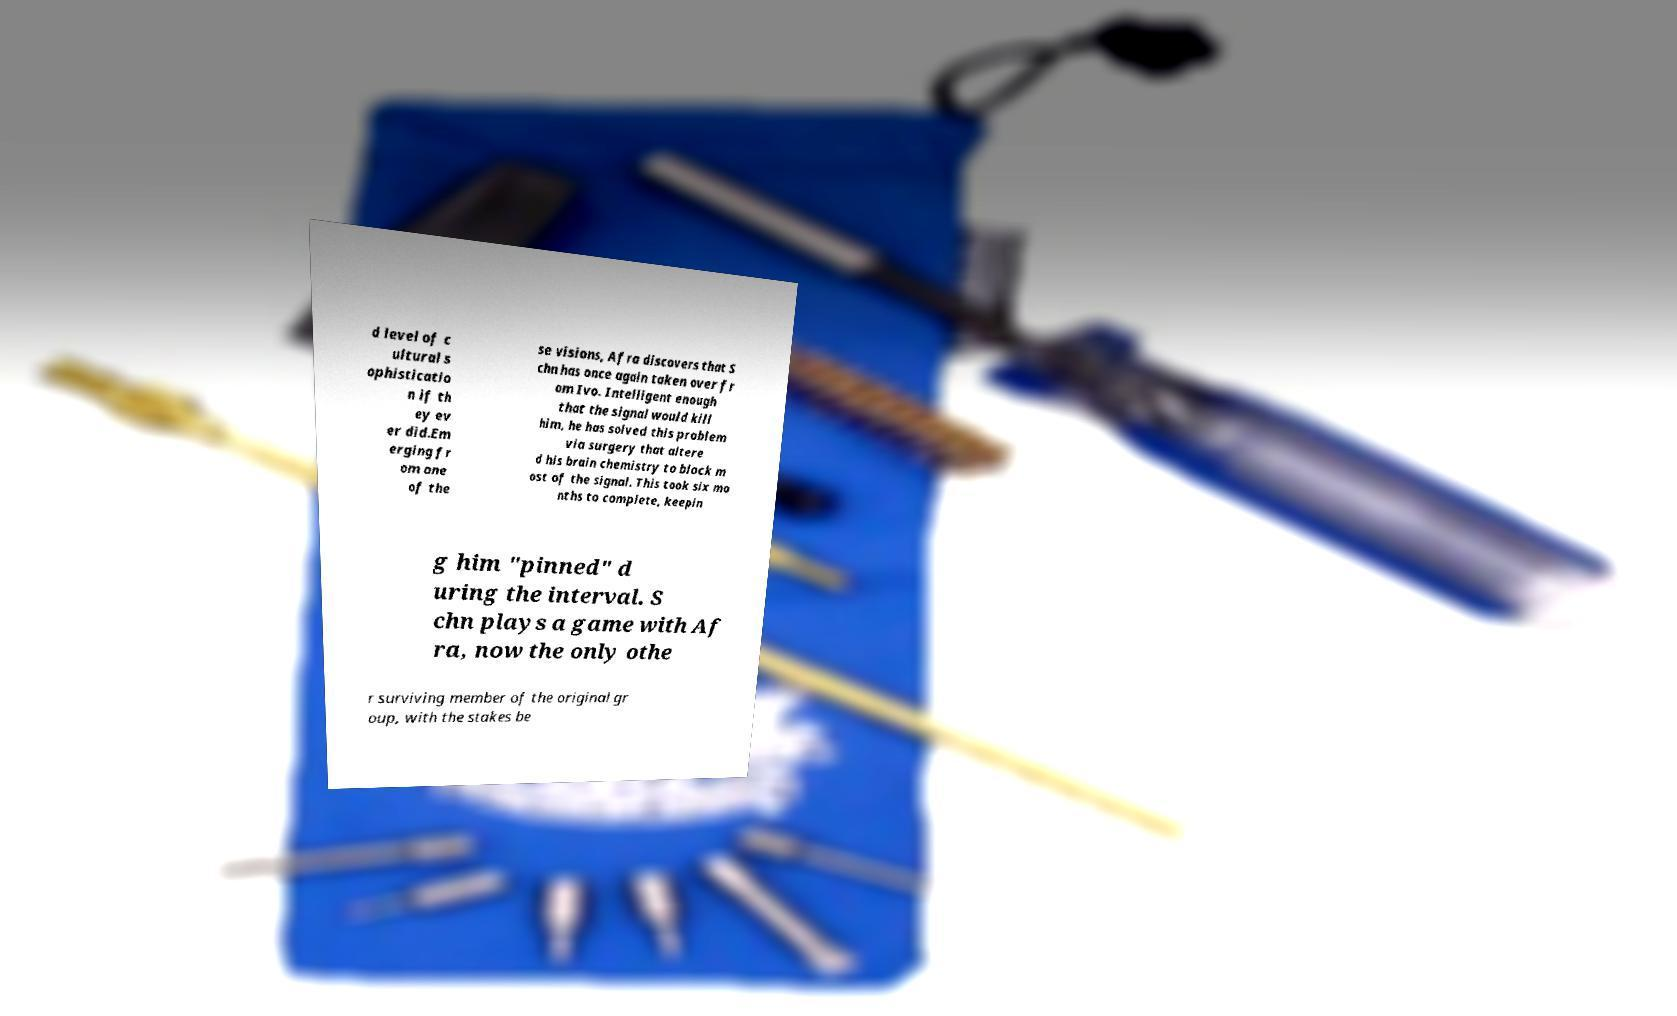Please read and relay the text visible in this image. What does it say? d level of c ultural s ophisticatio n if th ey ev er did.Em erging fr om one of the se visions, Afra discovers that S chn has once again taken over fr om Ivo. Intelligent enough that the signal would kill him, he has solved this problem via surgery that altere d his brain chemistry to block m ost of the signal. This took six mo nths to complete, keepin g him "pinned" d uring the interval. S chn plays a game with Af ra, now the only othe r surviving member of the original gr oup, with the stakes be 